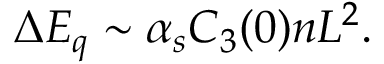<formula> <loc_0><loc_0><loc_500><loc_500>\Delta E _ { q } \sim \alpha _ { s } C _ { 3 } ( 0 ) n L ^ { 2 } .</formula> 